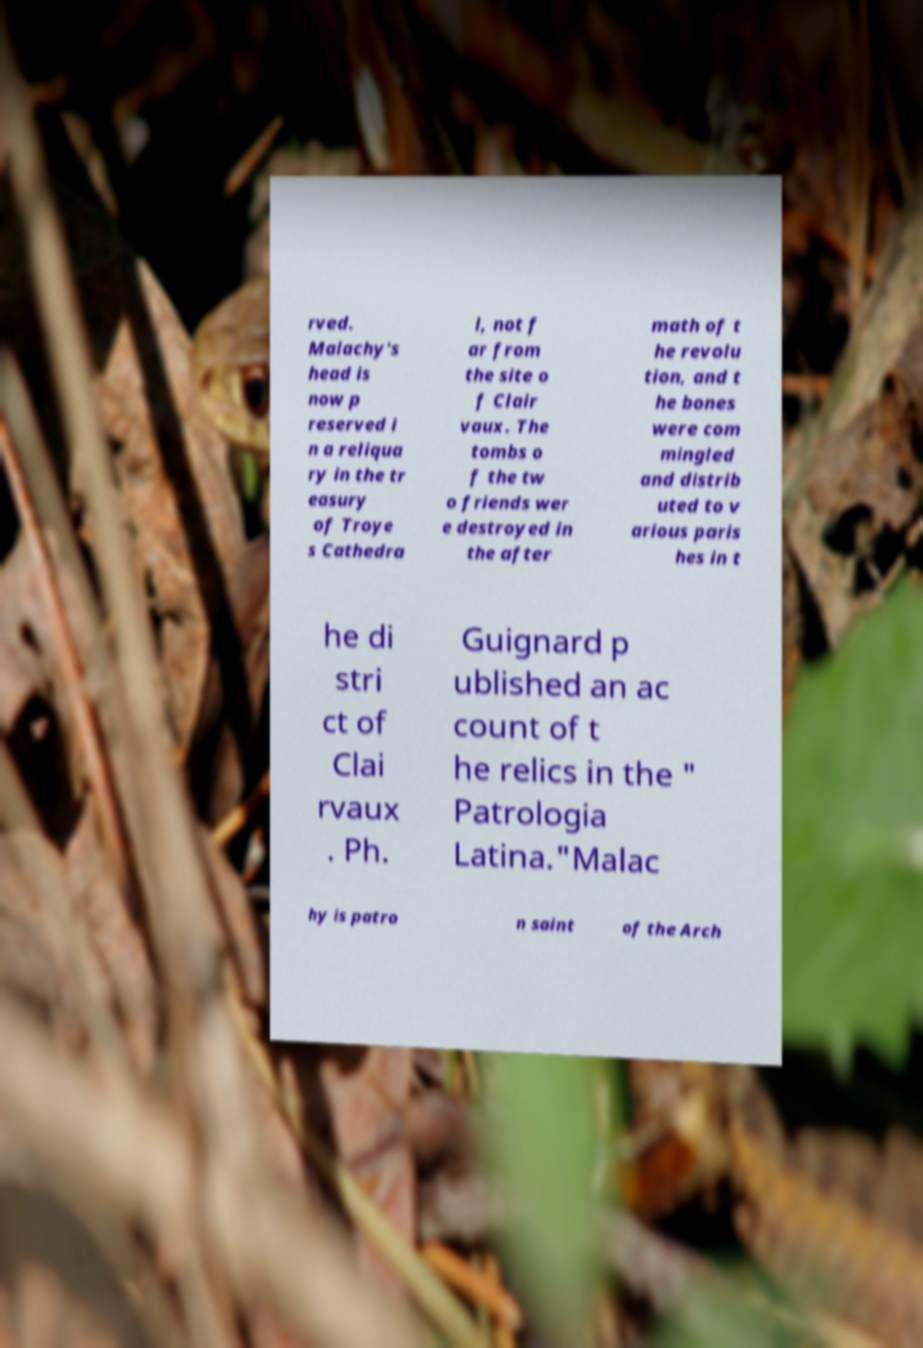Can you accurately transcribe the text from the provided image for me? rved. Malachy's head is now p reserved i n a reliqua ry in the tr easury of Troye s Cathedra l, not f ar from the site o f Clair vaux. The tombs o f the tw o friends wer e destroyed in the after math of t he revolu tion, and t he bones were com mingled and distrib uted to v arious paris hes in t he di stri ct of Clai rvaux . Ph. Guignard p ublished an ac count of t he relics in the " Patrologia Latina."Malac hy is patro n saint of the Arch 